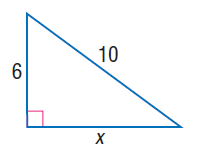Question: Find x.
Choices:
A. 6
B. 8
C. 10
D. 2 \sqrt { 34 }
Answer with the letter. Answer: B 